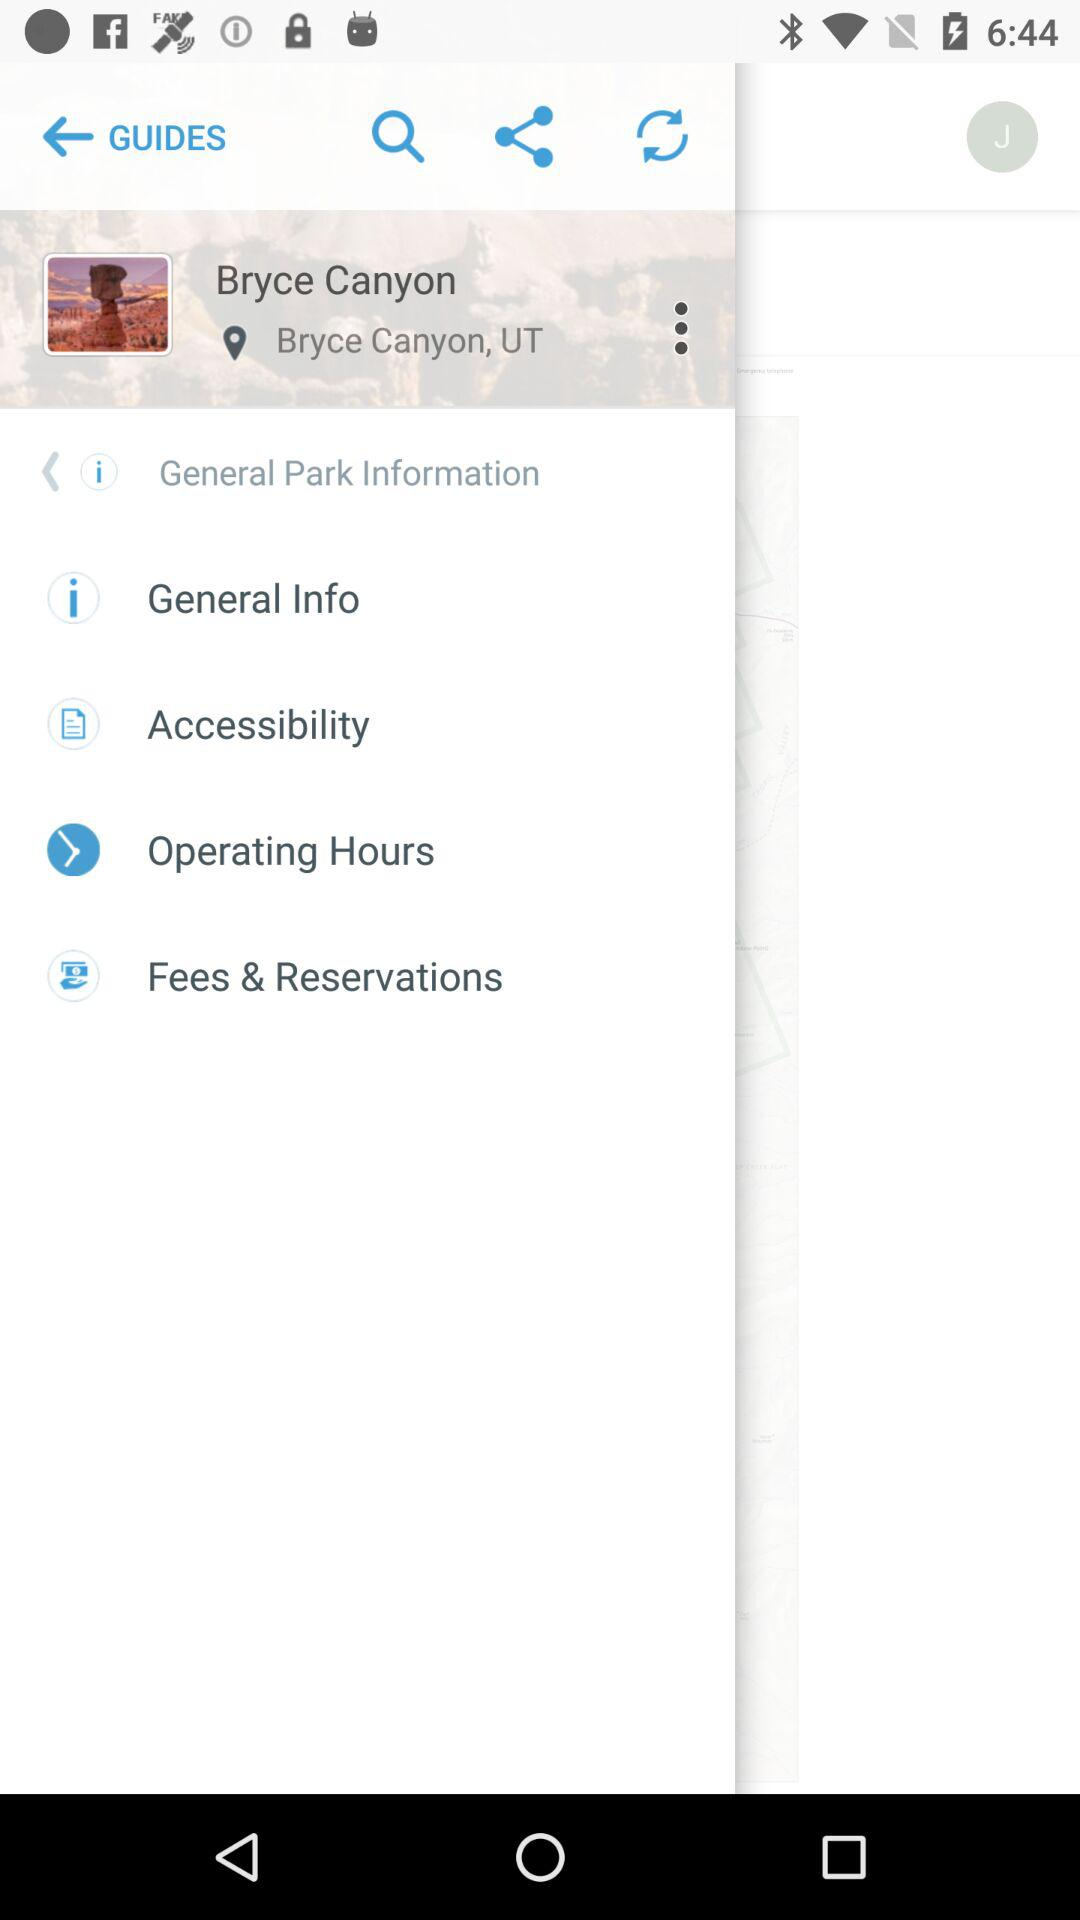What's the name of the park? The name of the park is Bryce Canyon. 